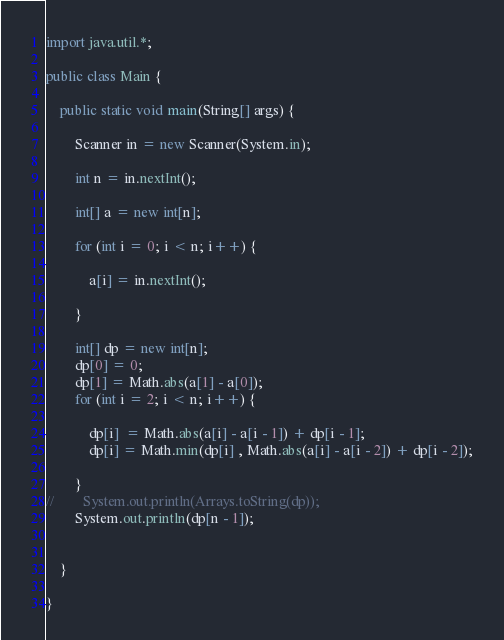Convert code to text. <code><loc_0><loc_0><loc_500><loc_500><_Java_>
import java.util.*;

public class Main {

    public static void main(String[] args) {
        
        Scanner in = new Scanner(System.in);
        
        int n = in.nextInt();
        
        int[] a = new int[n];
        
        for (int i = 0; i < n; i++) {
            
            a[i] = in.nextInt();
            
        }
        
        int[] dp = new int[n];
        dp[0] = 0;
        dp[1] = Math.abs(a[1] - a[0]);
        for (int i = 2; i < n; i++) {
            
            dp[i]  = Math.abs(a[i] - a[i - 1]) + dp[i - 1];
            dp[i] = Math.min(dp[i] , Math.abs(a[i] - a[i - 2]) + dp[i - 2]);
            
        }
//        System.out.println(Arrays.toString(dp));
        System.out.println(dp[n - 1]);
        
        
    }
    
}
</code> 